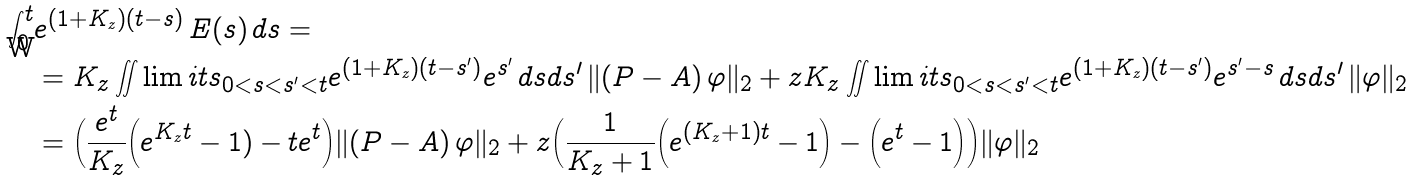<formula> <loc_0><loc_0><loc_500><loc_500>\int _ { 0 } ^ { t } & e ^ { ( 1 + K _ { z } ) ( t - s ) } \, E ( s ) \, d s = \\ & = K _ { z } \iint \lim i t s _ { 0 < s < s ^ { \prime } < t } e ^ { ( 1 + K _ { z } ) ( t - s ^ { \prime } ) } e ^ { s ^ { \prime } } \, d s d s ^ { \prime } \, \| ( P - A ) \, \varphi \| _ { 2 } + z K _ { z } \iint \lim i t s _ { 0 < s < s ^ { \prime } < t } e ^ { ( 1 + K _ { z } ) ( t - s ^ { \prime } ) } e ^ { s ^ { \prime } - s } \, d s d s ^ { \prime } \, \| \varphi \| _ { 2 } \\ & = \Big ( \frac { e ^ { t } } { K _ { z } } \Big ( e ^ { K _ { z } t } - 1 ) - t e ^ { t } \Big ) \| ( P - A ) \, \varphi \| _ { 2 } + z \Big ( \frac { 1 } { K _ { z } + 1 } \Big ( e ^ { ( K _ { z } + 1 ) t } - 1 \Big ) - \Big ( e ^ { t } - 1 \Big ) \Big ) \| \varphi \| _ { 2 }</formula> 